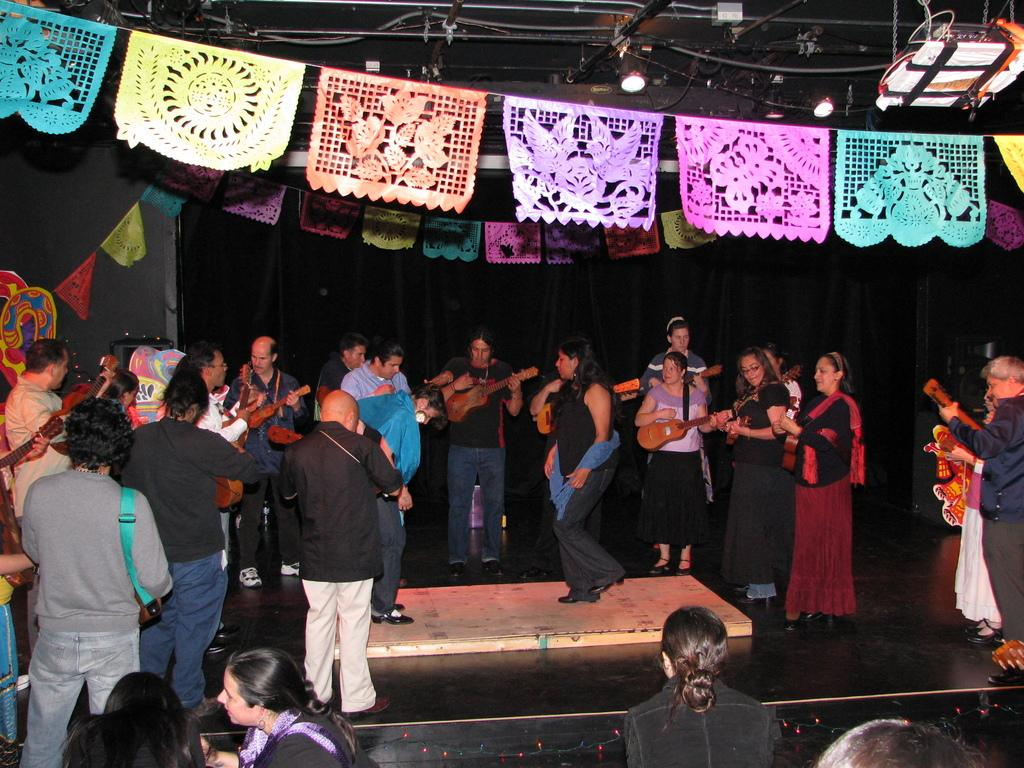What are the people in the center of the image doing? The people are playing musical instruments. What can be seen at the top of the image? There are decorations and lights at the top of the image. What is the surface that the people are standing on? There is a floor at the bottom of the image. What type of sweater is the surprise wearing in the image? There is no surprise or sweater present in the image. 